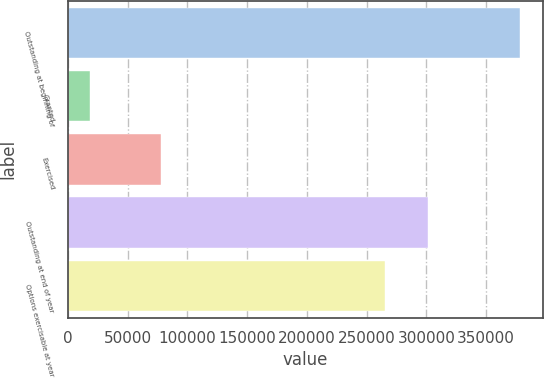Convert chart to OTSL. <chart><loc_0><loc_0><loc_500><loc_500><bar_chart><fcel>Outstanding at beginning of<fcel>Granted<fcel>Exercised<fcel>Outstanding at end of year<fcel>Options exercisable at year<nl><fcel>378542<fcel>18214<fcel>78381<fcel>301803<fcel>265770<nl></chart> 